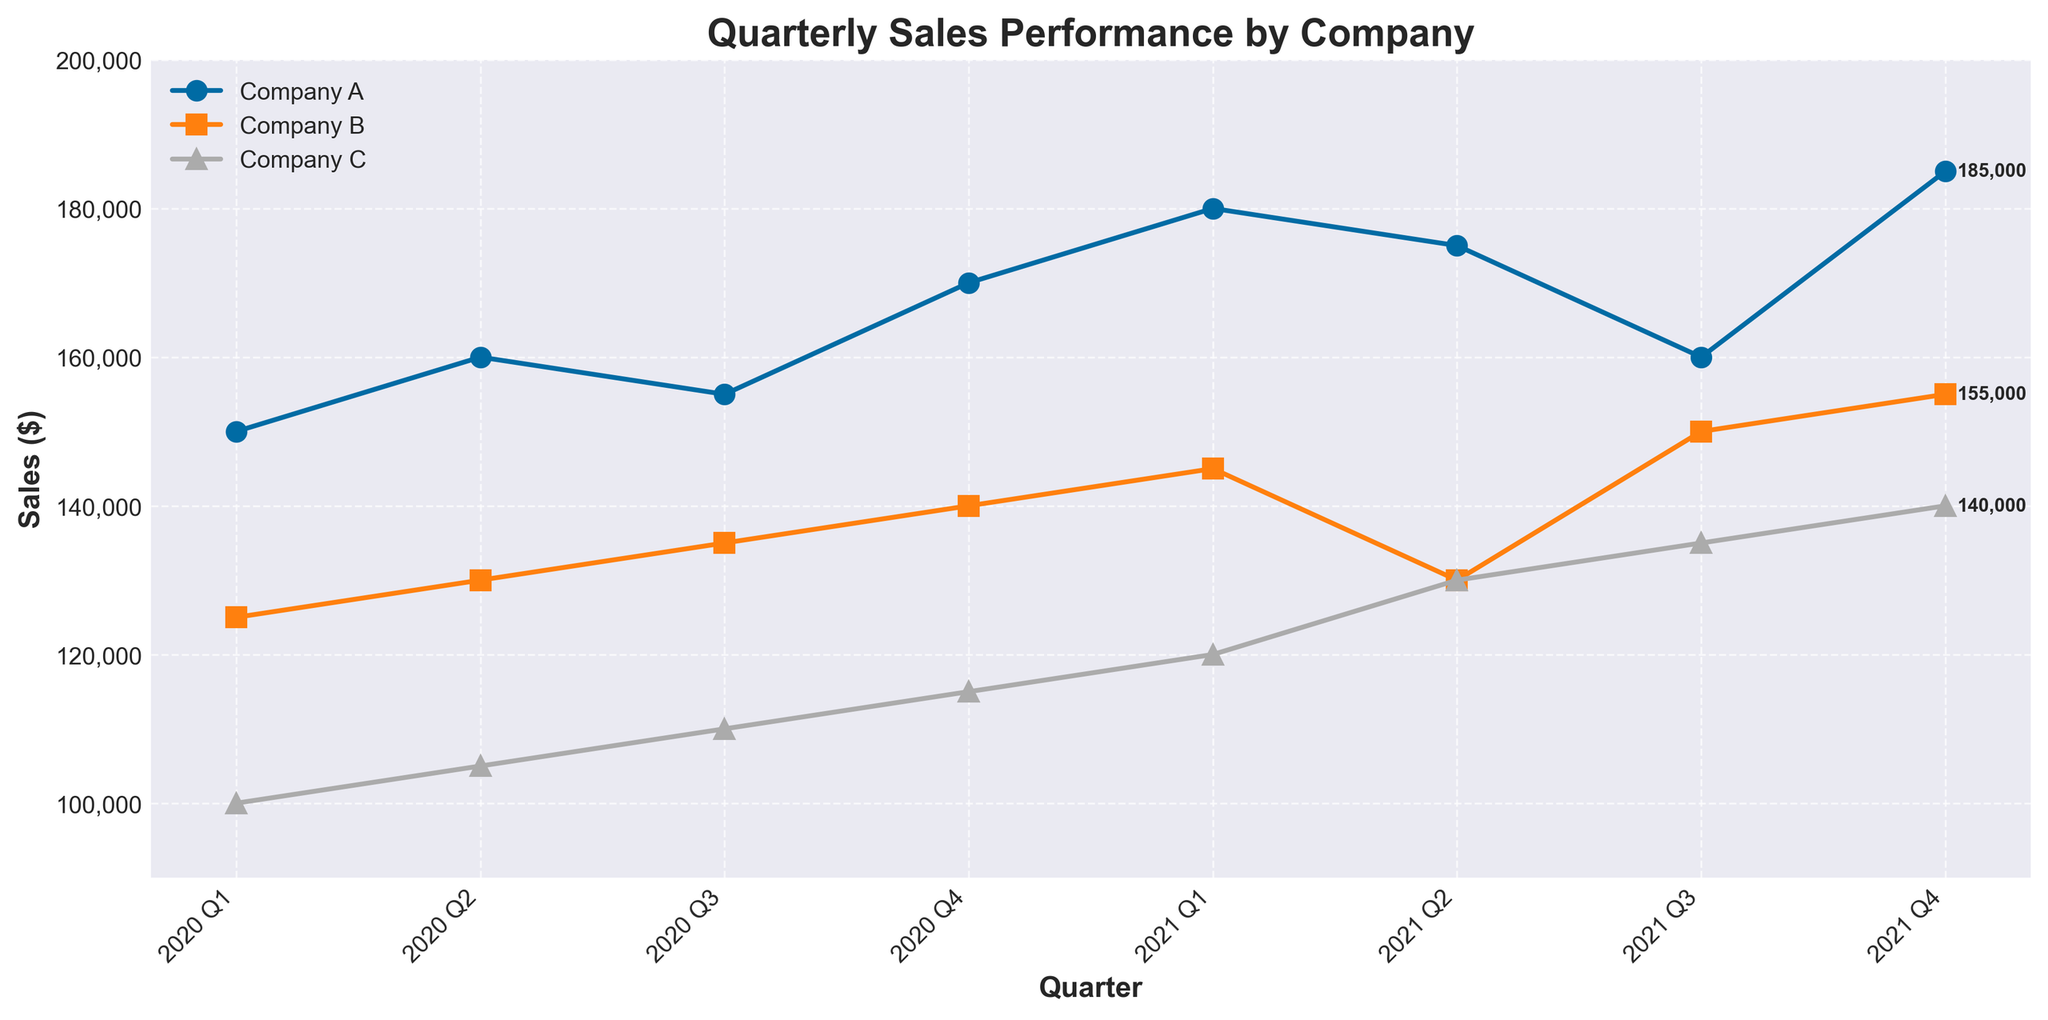What is the title of the plot? The title of the plot is located at the top center and provides a description of what the plot is about.
Answer: Quarterly Sales Performance by Company What is the sales figure for Company B in 2021 Q1? First, identify the data points for Company B, then locate the one corresponding to 2021 Q1. The sales figure associated with this point is the value to be found.
Answer: 145,000 What was the trend in sales for Company A from 2020 Q1 to 2021 Q1? Examine the data points for Company A over the specified time period. The plot shows an upward trend as the sales figures increase consistently from 150,000 in 2020 Q1 to 180,000 in 2021 Q1.
Answer: Increasing Which company had the highest sales in 2021 Q4? Look at the data points for 2021 Q4 and identify the highest value among the competitors. Company A had the highest sales with a sales figure of 185,000.
Answer: Company A What is the range of sales values for Company C in the given data? Find the minimum and maximum sales values for Company C, then calculate the difference between them. The minimum sales value is 100,000 (2020 Q1) and the maximum is 140,000 (2021 Q4), so the range is 140,000 - 100,000 = 40,000.
Answer: 40,000 How does the sales trend for Company B compare between the first and second quarters of 2021? Compare the sales figures for Company B from 2021 Q1 and 2021 Q2. Sales decreased from 145,000 to 130,000.
Answer: Decreasing In which quarter was the sales difference between Company A and Company C the greatest, and what was the difference? Calculate the sales differences for each quarter and identify the greatest one. The most considerable difference occurred in 2021 Q1, where Company A's sales were 180,000 and Company C's were 120,000, resulting in a difference of 60,000.
Answer: 2021 Q1, 60,000 What is the average sales figure for Company B across all quarters shown? Sum the sales figures for Company B across all quarters and divide by the number of quarters. (125,000 + 130,000 + 135,000 + 140,000 + 145,000 + 130,000 + 150,000 + 155,000) / 8 ≈ 138,750
Answer: 138,750 Was there any quarter where sales for all three companies increased compared to the previous quarter? Observe the data points for all three companies and compare each quarter with the previous one. Q1 to Q2 in 2020 shows an increase for all three companies: Company A (150,000 to 160,000), Company B (125,000 to 130,000), and Company C (100,000 to 105,000).
Answer: Yes, 2020 Q1 to Q2 Which company had the most consistent sales (least fluctuation) over the given time periods? Examine the sales figures for each company and calculate the variance to find the one with the least fluctuation. Company C shows the least fluctuation with gradually increasing sales figures.
Answer: Company C 